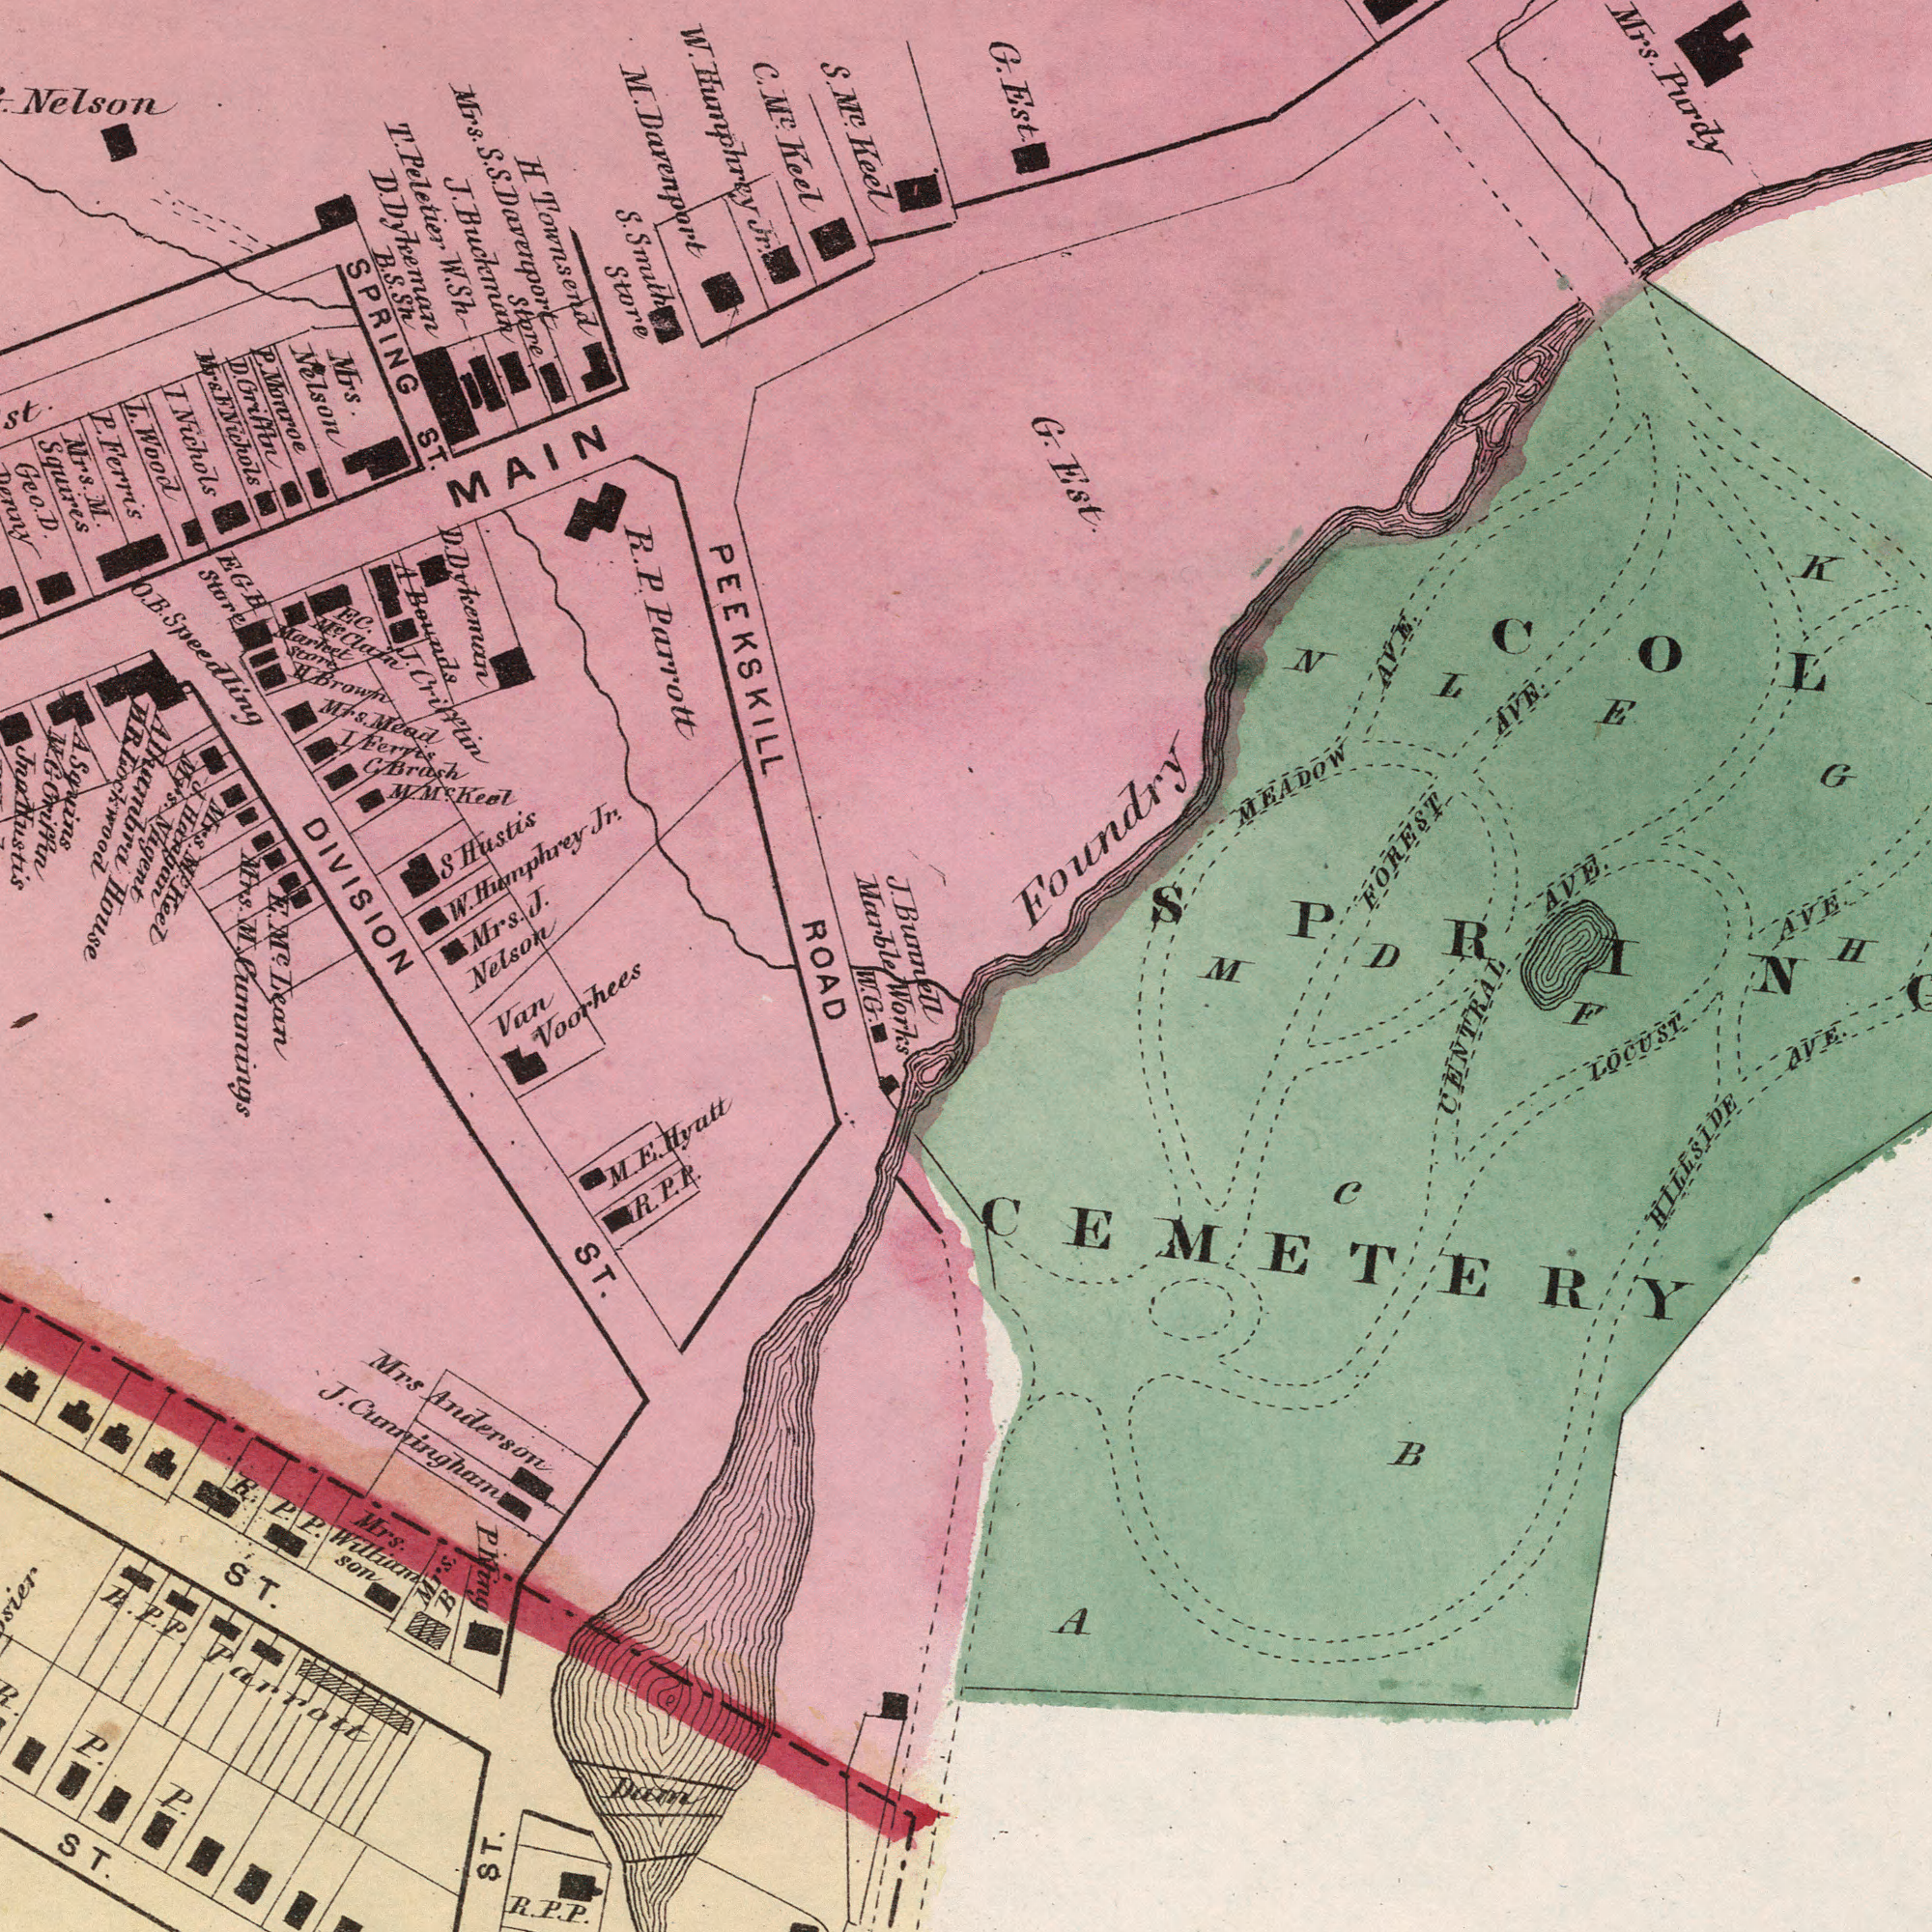What text appears in the top-right area of the image? G. Est. MEADOW AVE. G. Est. FOREST AVE. AVE. AVE. K Foundry H Mrs. Purdy COL D N L E G What text is shown in the bottom-right quadrant? LOCUST CENTRAL F B HILLSIDE AVE. A C CEMETERY M What text can you see in the top-left section? PEEKSKILL R. P. Parrott Nelson SPRING ST. L. Wood J. Buchman S. M<sup>c</sup>. Keel C. M<sup>c</sup>. keel H Townsend Mrs. M. Squires DIVISION I Nichols J. Crifftin W. Humphrey Jr. S. Smith Store S Hustis Mrs. S. S. Davenport Store W. Humphrey Jr. MAIN Mrs. Mead Mrs. Nelson T. Peletier W. Sh M. Davenport Mrs. M. Market Store H. Brown P. Monroe EGH Store EC. M<sup>c</sup>. Clain I Ferris J. Bunnell Marble Bounds P. Ferris D. Dykeman E. M<sup>c</sup>. D. Dyleeman B. S. Sh D. Griffin Mrs. F Nichols Geo. D. C. Brash M. M<sup>c</sup>. Keel Mrs. J. Nelson O. B. Speedling Mrs. M<sup>c</sup>. Keel J. Hangan Mrs. Nagent Alhambra House H. B. Lockwood A Squins M. G Griffin Jno. Hustis St. What text can you see in the bottom-left section? ROAD ST. Cummings Works W. G. Mrs Anderson J. Cunningham Parrott Lean ST. Van Voorhees M. E. Hyatt ST. ST. P. P. Mrs. William Son R. P. P. P King Mrs. B R. P. P. R. P. P. R. P. P. Dam 